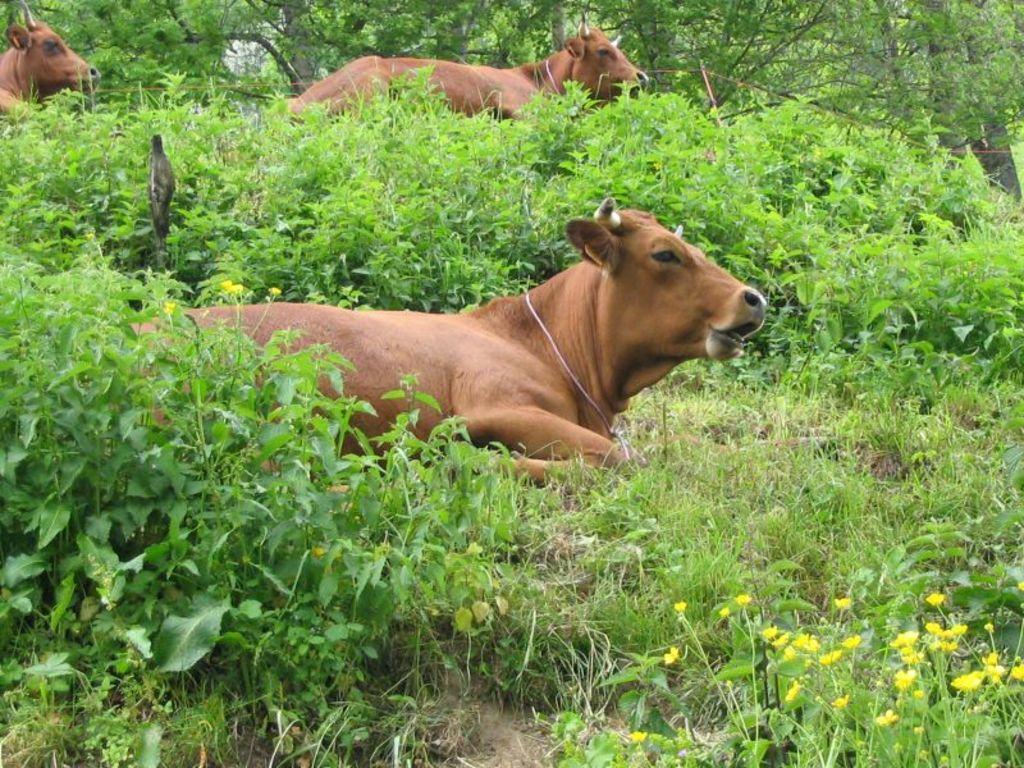In one or two sentences, can you explain what this image depicts? In this picture we can see a cow sitting on the grass. There are two cows and trees are visible in the background. 